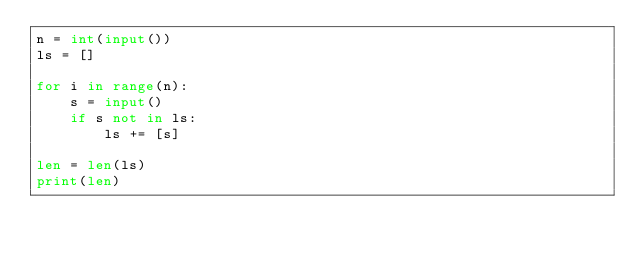Convert code to text. <code><loc_0><loc_0><loc_500><loc_500><_Python_>n = int(input())
ls = []

for i in range(n):
    s = input()
    if s not in ls:
        ls += [s]

len = len(ls)
print(len)

</code> 